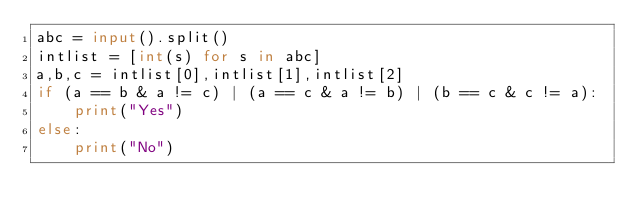<code> <loc_0><loc_0><loc_500><loc_500><_Python_>abc = input().split()
intlist = [int(s) for s in abc]
a,b,c = intlist[0],intlist[1],intlist[2]
if (a == b & a != c) | (a == c & a != b) | (b == c & c != a):
    print("Yes")
else:
    print("No")


</code> 